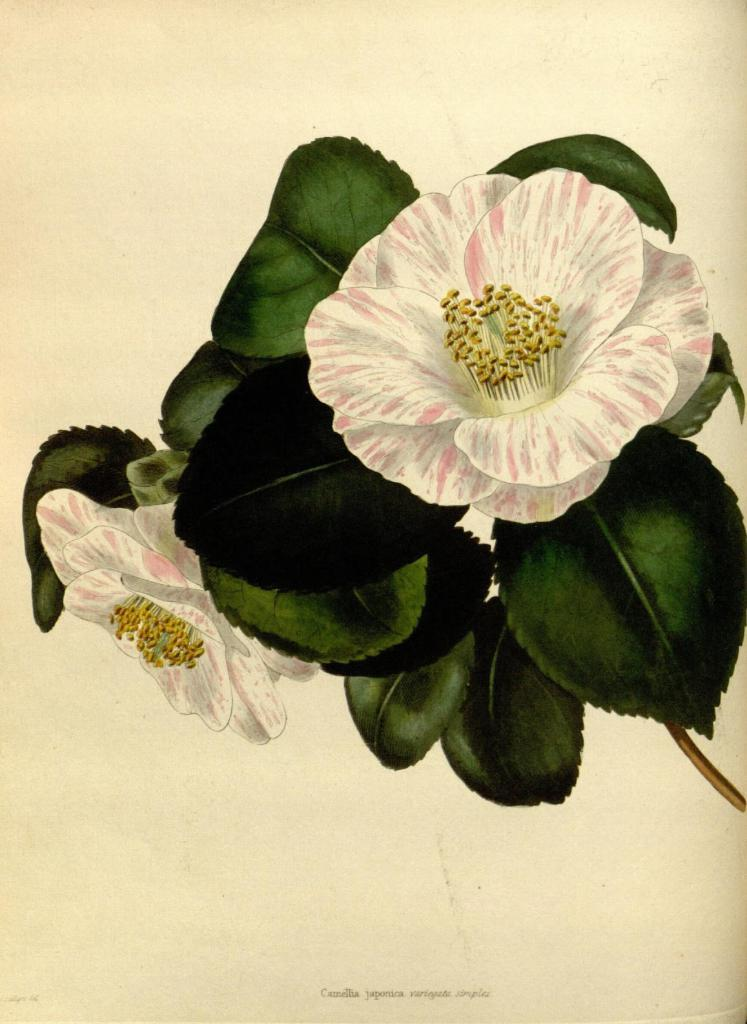What type of artwork is depicted in the image? The image is a drawing. What natural elements can be seen in the drawing? There are flowers and leaves in the drawing. How many goldfish are swimming in the basin in the drawing? There are no goldfish or basin present in the drawing; it features flowers and leaves. 